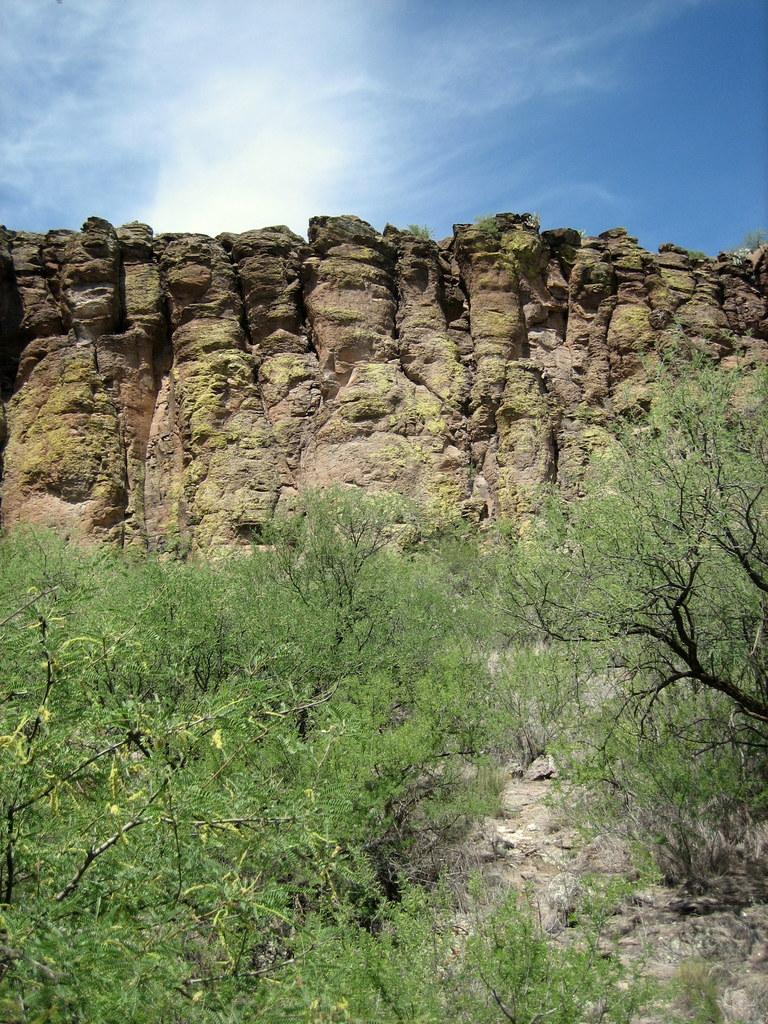What type of vegetation is in the foreground of the image? There are trees in the foreground of the image. What geological feature is located in the middle of the image? There is a cliff in the middle of the image. What is visible at the top of the image? The sky is visible at the top of the image. What can be seen in the sky in the image? Clouds are present in the sky. What caption is written on the trees in the image? There is no caption written on the trees in the image; they are simply depicted as vegetation in the foreground. 